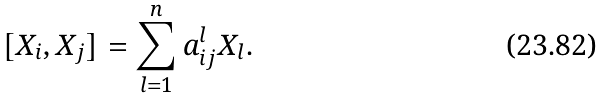Convert formula to latex. <formula><loc_0><loc_0><loc_500><loc_500>[ X _ { i } , X _ { j } ] = \sum _ { l = 1 } ^ { n } a _ { i j } ^ { l } X _ { l } .</formula> 